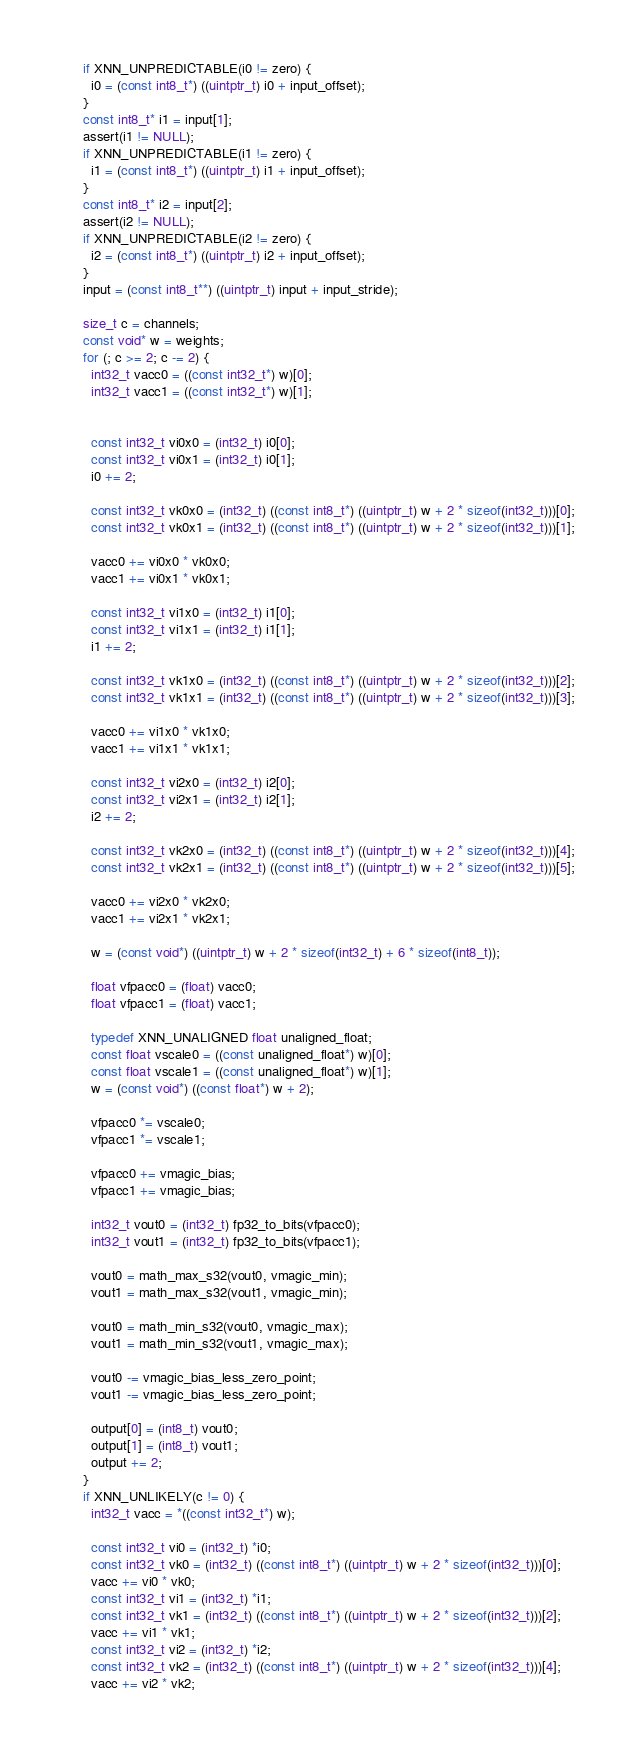Convert code to text. <code><loc_0><loc_0><loc_500><loc_500><_C_>    if XNN_UNPREDICTABLE(i0 != zero) {
      i0 = (const int8_t*) ((uintptr_t) i0 + input_offset);
    }
    const int8_t* i1 = input[1];
    assert(i1 != NULL);
    if XNN_UNPREDICTABLE(i1 != zero) {
      i1 = (const int8_t*) ((uintptr_t) i1 + input_offset);
    }
    const int8_t* i2 = input[2];
    assert(i2 != NULL);
    if XNN_UNPREDICTABLE(i2 != zero) {
      i2 = (const int8_t*) ((uintptr_t) i2 + input_offset);
    }
    input = (const int8_t**) ((uintptr_t) input + input_stride);

    size_t c = channels;
    const void* w = weights;
    for (; c >= 2; c -= 2) {
      int32_t vacc0 = ((const int32_t*) w)[0];
      int32_t vacc1 = ((const int32_t*) w)[1];


      const int32_t vi0x0 = (int32_t) i0[0];
      const int32_t vi0x1 = (int32_t) i0[1];
      i0 += 2;

      const int32_t vk0x0 = (int32_t) ((const int8_t*) ((uintptr_t) w + 2 * sizeof(int32_t)))[0];
      const int32_t vk0x1 = (int32_t) ((const int8_t*) ((uintptr_t) w + 2 * sizeof(int32_t)))[1];

      vacc0 += vi0x0 * vk0x0;
      vacc1 += vi0x1 * vk0x1;

      const int32_t vi1x0 = (int32_t) i1[0];
      const int32_t vi1x1 = (int32_t) i1[1];
      i1 += 2;

      const int32_t vk1x0 = (int32_t) ((const int8_t*) ((uintptr_t) w + 2 * sizeof(int32_t)))[2];
      const int32_t vk1x1 = (int32_t) ((const int8_t*) ((uintptr_t) w + 2 * sizeof(int32_t)))[3];

      vacc0 += vi1x0 * vk1x0;
      vacc1 += vi1x1 * vk1x1;

      const int32_t vi2x0 = (int32_t) i2[0];
      const int32_t vi2x1 = (int32_t) i2[1];
      i2 += 2;

      const int32_t vk2x0 = (int32_t) ((const int8_t*) ((uintptr_t) w + 2 * sizeof(int32_t)))[4];
      const int32_t vk2x1 = (int32_t) ((const int8_t*) ((uintptr_t) w + 2 * sizeof(int32_t)))[5];

      vacc0 += vi2x0 * vk2x0;
      vacc1 += vi2x1 * vk2x1;

      w = (const void*) ((uintptr_t) w + 2 * sizeof(int32_t) + 6 * sizeof(int8_t));

      float vfpacc0 = (float) vacc0;
      float vfpacc1 = (float) vacc1;

      typedef XNN_UNALIGNED float unaligned_float;
      const float vscale0 = ((const unaligned_float*) w)[0];
      const float vscale1 = ((const unaligned_float*) w)[1];
      w = (const void*) ((const float*) w + 2);

      vfpacc0 *= vscale0;
      vfpacc1 *= vscale1;

      vfpacc0 += vmagic_bias;
      vfpacc1 += vmagic_bias;

      int32_t vout0 = (int32_t) fp32_to_bits(vfpacc0);
      int32_t vout1 = (int32_t) fp32_to_bits(vfpacc1);

      vout0 = math_max_s32(vout0, vmagic_min);
      vout1 = math_max_s32(vout1, vmagic_min);

      vout0 = math_min_s32(vout0, vmagic_max);
      vout1 = math_min_s32(vout1, vmagic_max);

      vout0 -= vmagic_bias_less_zero_point;
      vout1 -= vmagic_bias_less_zero_point;

      output[0] = (int8_t) vout0;
      output[1] = (int8_t) vout1;
      output += 2;
    }
    if XNN_UNLIKELY(c != 0) {
      int32_t vacc = *((const int32_t*) w);

      const int32_t vi0 = (int32_t) *i0;
      const int32_t vk0 = (int32_t) ((const int8_t*) ((uintptr_t) w + 2 * sizeof(int32_t)))[0];
      vacc += vi0 * vk0;
      const int32_t vi1 = (int32_t) *i1;
      const int32_t vk1 = (int32_t) ((const int8_t*) ((uintptr_t) w + 2 * sizeof(int32_t)))[2];
      vacc += vi1 * vk1;
      const int32_t vi2 = (int32_t) *i2;
      const int32_t vk2 = (int32_t) ((const int8_t*) ((uintptr_t) w + 2 * sizeof(int32_t)))[4];
      vacc += vi2 * vk2;
</code> 